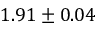<formula> <loc_0><loc_0><loc_500><loc_500>1 . 9 1 \pm 0 . 0 4</formula> 